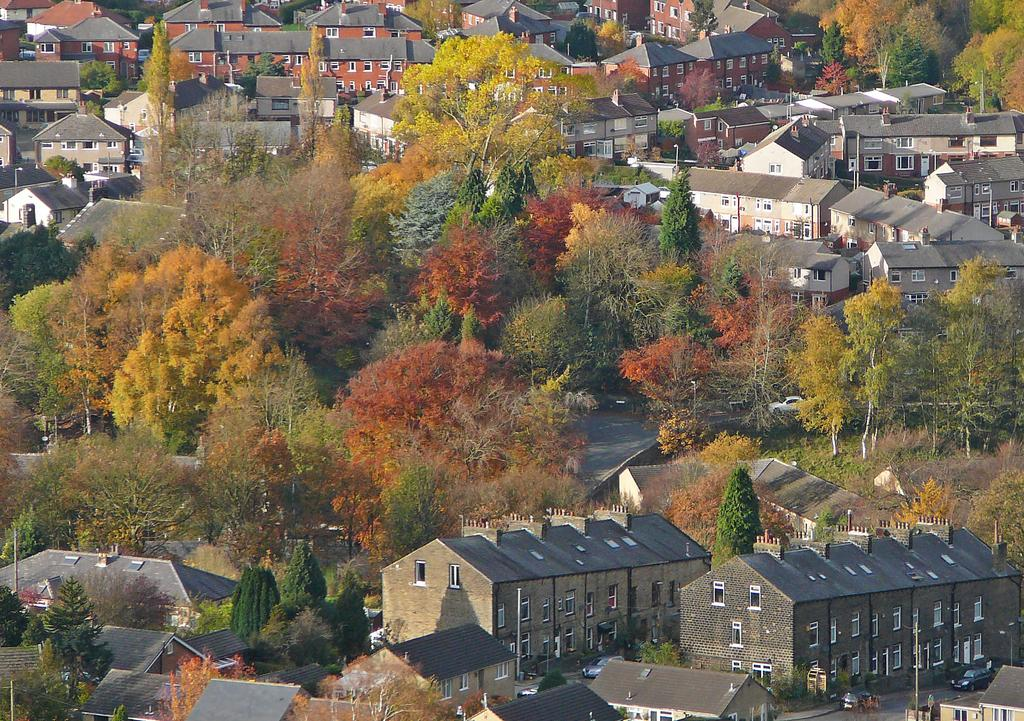What type of natural elements can be seen in the image? There are trees in the image. What type of man-made structures are present in the image? There are buildings in the image. What type of transportation is visible in the image? There are vehicles in the image. What type of vertical structures can be seen in the image? There are poles in the image. What type of wool is being spun by the sheep in the image? There are no sheep or wool present in the image. What is the tendency of the land in the image to produce crops? There is no land or crops present in the image. 